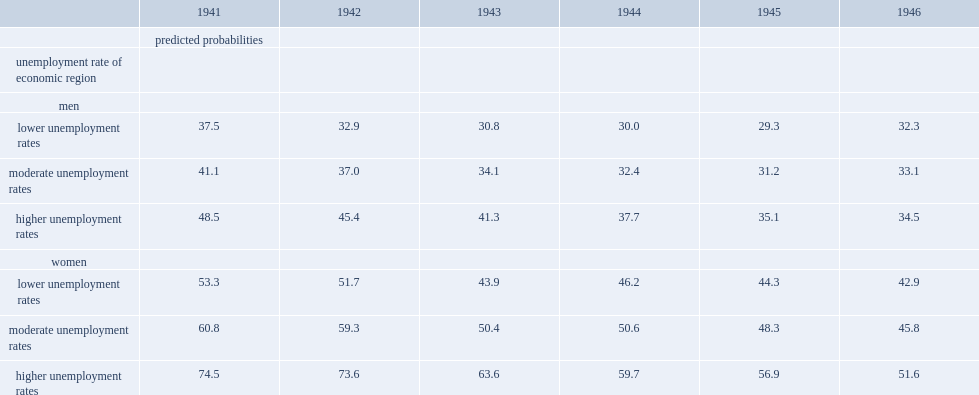What is the probability of a woman from the 1941 cohort would retire before age 62 if she resided in an er with a higher unemployment rate? 74.5. What proportion of the working women in 1941 with a higher unemployment rate would retire before age 62? 0.745. What is the probability of working women in 1941 with lower unemployment rates would retire before age 62? 53.3. What is the difference between working women in 1941 who would retire before age 62 with lower unemployment rates and higher unemployment rates? 21.2. What is the difference between those with lower unemployment rates and higher unemployment rates among men who were born in 1941 predicted to retire before age 62? 11. What is the probability of retiring before age 62 among male employees who were born in 1941 living in regions with a higher unemployment rate? 48.5. What is the probability of retiring before age 62 among male employees who were born in 1941 living in regions with a higher unemployment rate? 37.5. 